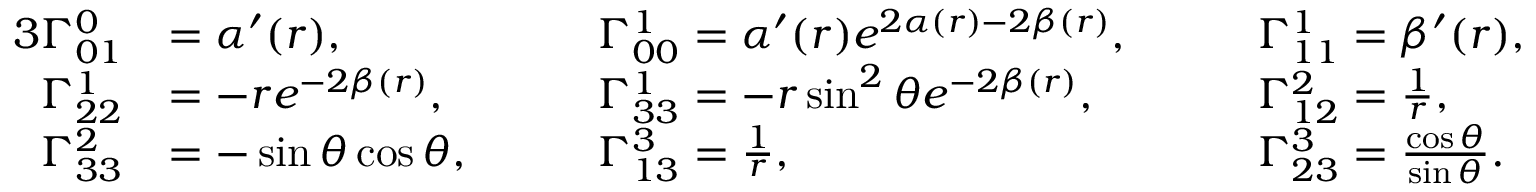<formula> <loc_0><loc_0><loc_500><loc_500>\begin{array} { r l r l r l } { { 3 } \Gamma _ { 0 1 } ^ { 0 } } & { = \alpha ^ { \prime } ( r ) , \quad } & & { \Gamma _ { 0 0 } ^ { 1 } = \alpha ^ { \prime } ( r ) e ^ { 2 \alpha ( r ) - 2 \beta ( r ) } , \quad } & & { \Gamma _ { 1 1 } ^ { 1 } = \beta ^ { \prime } ( r ) , } \\ { \Gamma _ { 2 2 } ^ { 1 } } & { = - r e ^ { - 2 \beta ( r ) } , \quad } & & { \Gamma _ { 3 3 } ^ { 1 } = - r \sin ^ { 2 } \theta e ^ { - 2 \beta ( r ) } , \quad } & & { \Gamma _ { 1 2 } ^ { 2 } = \frac { 1 } { r } , } \\ { \Gamma _ { 3 3 } ^ { 2 } } & { = - \sin \theta \cos \theta , \quad } & & { \Gamma _ { 1 3 } ^ { 3 } = \frac { 1 } { r } , \quad } & & { \Gamma _ { 2 3 } ^ { 3 } = \frac { \cos \theta } { \sin \theta } . } \end{array}</formula> 